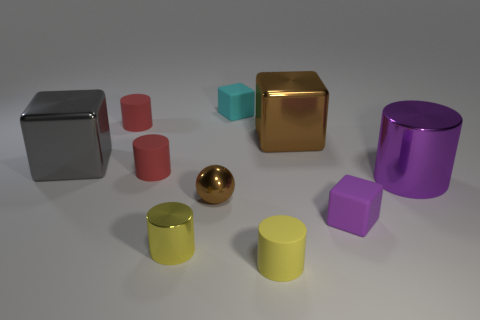Subtract all yellow cylinders. How many cylinders are left? 3 Subtract all yellow shiny cylinders. How many cylinders are left? 4 Subtract 0 blue cubes. How many objects are left? 10 Subtract all balls. How many objects are left? 9 Subtract 2 cylinders. How many cylinders are left? 3 Subtract all green balls. Subtract all red blocks. How many balls are left? 1 Subtract all purple cubes. How many red cylinders are left? 2 Subtract all purple metal blocks. Subtract all tiny red matte objects. How many objects are left? 8 Add 7 small cyan rubber blocks. How many small cyan rubber blocks are left? 8 Add 4 cyan cubes. How many cyan cubes exist? 5 